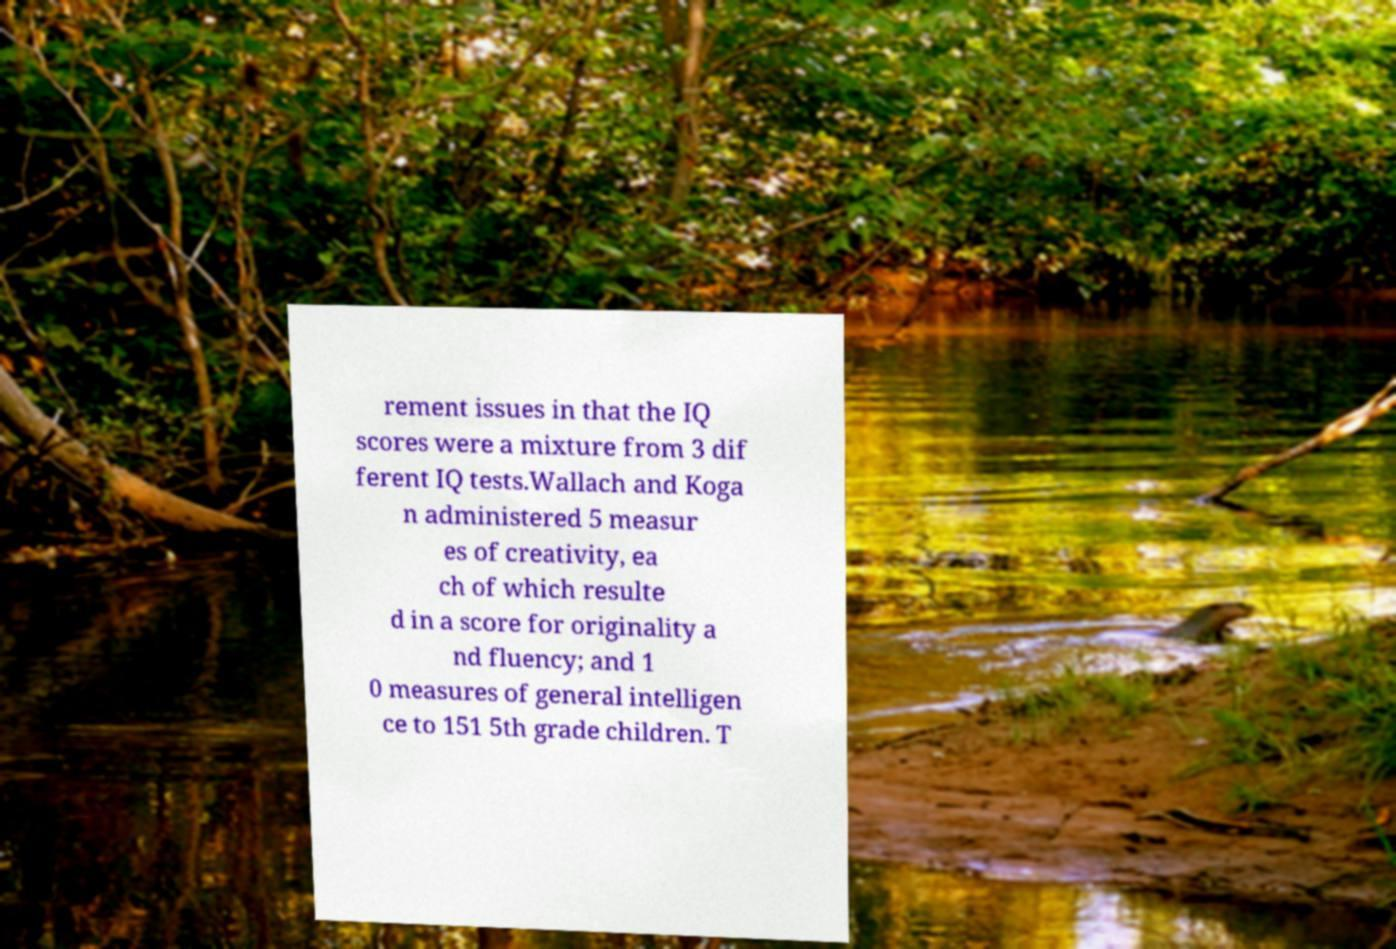Can you accurately transcribe the text from the provided image for me? rement issues in that the IQ scores were a mixture from 3 dif ferent IQ tests.Wallach and Koga n administered 5 measur es of creativity, ea ch of which resulte d in a score for originality a nd fluency; and 1 0 measures of general intelligen ce to 151 5th grade children. T 